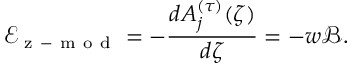<formula> <loc_0><loc_0><loc_500><loc_500>\mathcal { E } _ { z - m o d } = - \frac { d A _ { j } ^ { ( \tau ) } ( \zeta ) } { d \zeta } = - w \mathcal { B } .</formula> 